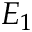Convert formula to latex. <formula><loc_0><loc_0><loc_500><loc_500>E _ { 1 }</formula> 